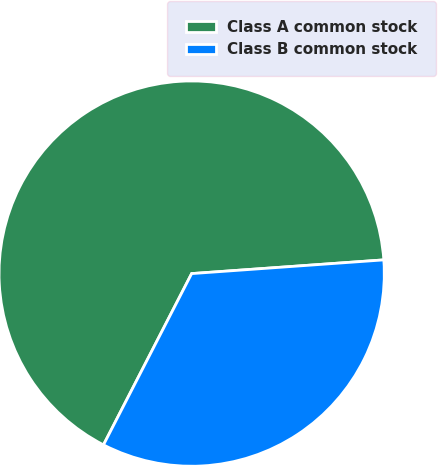<chart> <loc_0><loc_0><loc_500><loc_500><pie_chart><fcel>Class A common stock<fcel>Class B common stock<nl><fcel>66.3%<fcel>33.7%<nl></chart> 